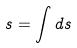Convert formula to latex. <formula><loc_0><loc_0><loc_500><loc_500>s = \int d s</formula> 